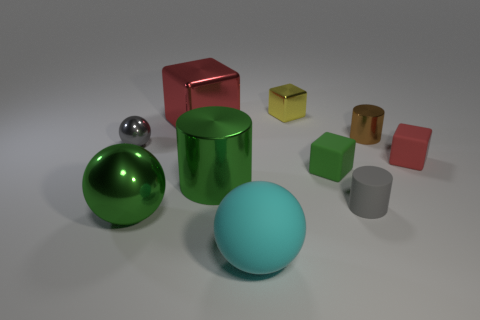Are there any matte cubes of the same color as the large shiny sphere?
Provide a succinct answer. Yes. There is a rubber thing that is the same color as the big shiny cylinder; what is its shape?
Offer a very short reply. Cube. What number of green things are either rubber objects or big balls?
Your response must be concise. 2. Is the material of the small gray sphere the same as the tiny brown cylinder?
Your answer should be very brief. Yes. What number of big cubes are in front of the small gray matte thing?
Offer a very short reply. 0. What material is the sphere that is both on the left side of the cyan sphere and in front of the small ball?
Your response must be concise. Metal. What number of cylinders are either green shiny things or red objects?
Keep it short and to the point. 1. What is the material of the big red object that is the same shape as the tiny yellow thing?
Your answer should be very brief. Metal. What is the size of the gray ball that is made of the same material as the tiny yellow object?
Ensure brevity in your answer.  Small. There is a gray thing in front of the small gray ball; is it the same shape as the red object that is to the right of the large matte sphere?
Provide a short and direct response. No. 